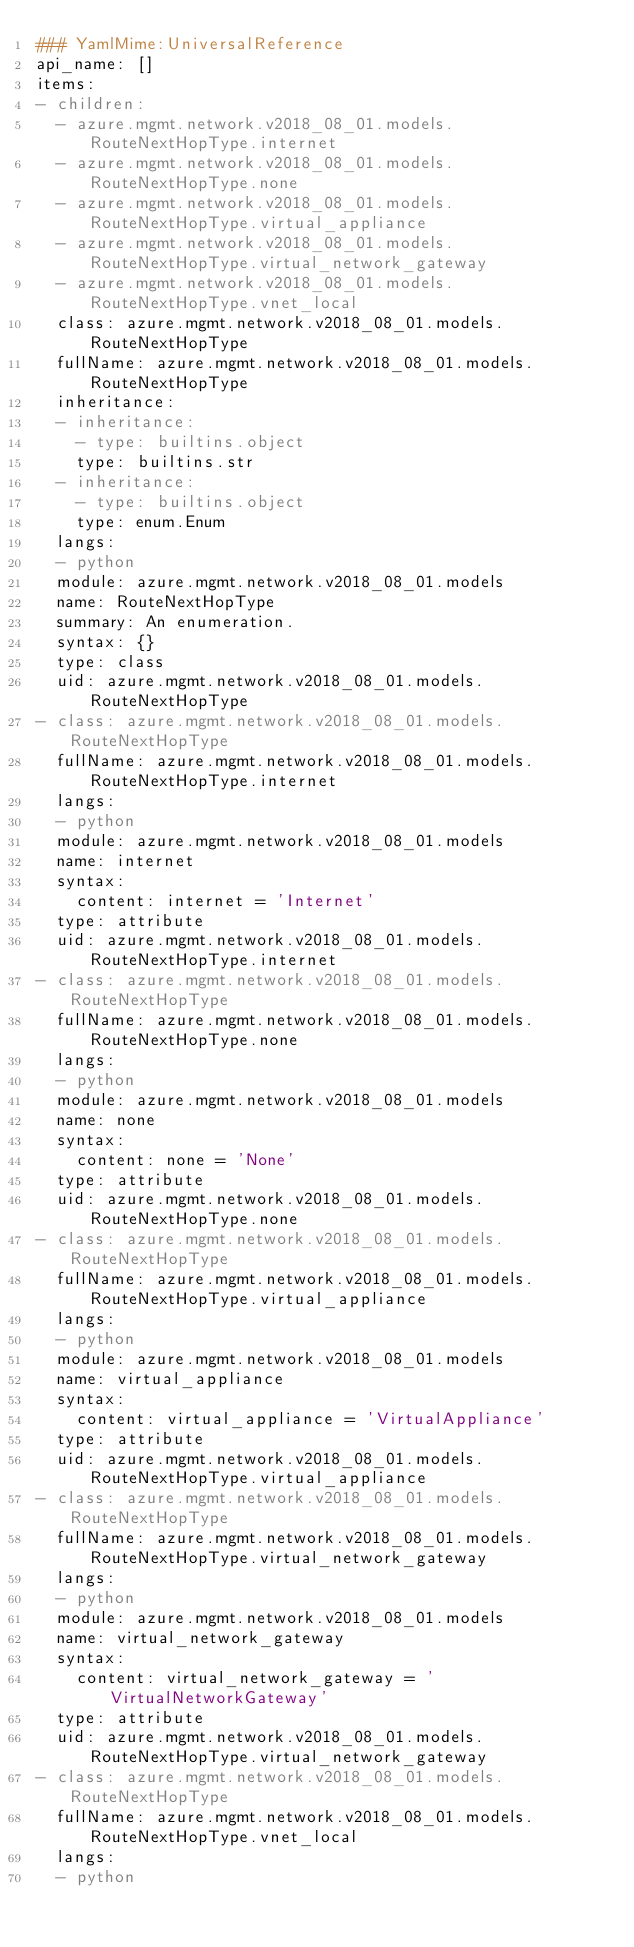Convert code to text. <code><loc_0><loc_0><loc_500><loc_500><_YAML_>### YamlMime:UniversalReference
api_name: []
items:
- children:
  - azure.mgmt.network.v2018_08_01.models.RouteNextHopType.internet
  - azure.mgmt.network.v2018_08_01.models.RouteNextHopType.none
  - azure.mgmt.network.v2018_08_01.models.RouteNextHopType.virtual_appliance
  - azure.mgmt.network.v2018_08_01.models.RouteNextHopType.virtual_network_gateway
  - azure.mgmt.network.v2018_08_01.models.RouteNextHopType.vnet_local
  class: azure.mgmt.network.v2018_08_01.models.RouteNextHopType
  fullName: azure.mgmt.network.v2018_08_01.models.RouteNextHopType
  inheritance:
  - inheritance:
    - type: builtins.object
    type: builtins.str
  - inheritance:
    - type: builtins.object
    type: enum.Enum
  langs:
  - python
  module: azure.mgmt.network.v2018_08_01.models
  name: RouteNextHopType
  summary: An enumeration.
  syntax: {}
  type: class
  uid: azure.mgmt.network.v2018_08_01.models.RouteNextHopType
- class: azure.mgmt.network.v2018_08_01.models.RouteNextHopType
  fullName: azure.mgmt.network.v2018_08_01.models.RouteNextHopType.internet
  langs:
  - python
  module: azure.mgmt.network.v2018_08_01.models
  name: internet
  syntax:
    content: internet = 'Internet'
  type: attribute
  uid: azure.mgmt.network.v2018_08_01.models.RouteNextHopType.internet
- class: azure.mgmt.network.v2018_08_01.models.RouteNextHopType
  fullName: azure.mgmt.network.v2018_08_01.models.RouteNextHopType.none
  langs:
  - python
  module: azure.mgmt.network.v2018_08_01.models
  name: none
  syntax:
    content: none = 'None'
  type: attribute
  uid: azure.mgmt.network.v2018_08_01.models.RouteNextHopType.none
- class: azure.mgmt.network.v2018_08_01.models.RouteNextHopType
  fullName: azure.mgmt.network.v2018_08_01.models.RouteNextHopType.virtual_appliance
  langs:
  - python
  module: azure.mgmt.network.v2018_08_01.models
  name: virtual_appliance
  syntax:
    content: virtual_appliance = 'VirtualAppliance'
  type: attribute
  uid: azure.mgmt.network.v2018_08_01.models.RouteNextHopType.virtual_appliance
- class: azure.mgmt.network.v2018_08_01.models.RouteNextHopType
  fullName: azure.mgmt.network.v2018_08_01.models.RouteNextHopType.virtual_network_gateway
  langs:
  - python
  module: azure.mgmt.network.v2018_08_01.models
  name: virtual_network_gateway
  syntax:
    content: virtual_network_gateway = 'VirtualNetworkGateway'
  type: attribute
  uid: azure.mgmt.network.v2018_08_01.models.RouteNextHopType.virtual_network_gateway
- class: azure.mgmt.network.v2018_08_01.models.RouteNextHopType
  fullName: azure.mgmt.network.v2018_08_01.models.RouteNextHopType.vnet_local
  langs:
  - python</code> 